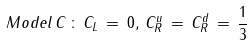Convert formula to latex. <formula><loc_0><loc_0><loc_500><loc_500>M o d e l \, C \, \colon \, { C _ { L } } \, = \, 0 , \, { C ^ { u } _ { R } } \, = \, { C ^ { d } _ { R } } \, = \, \frac { 1 } { 3 }</formula> 